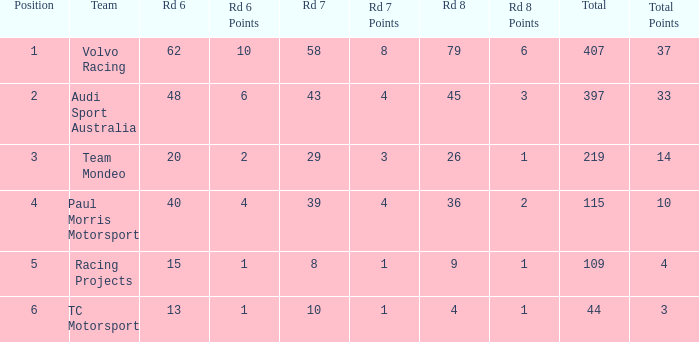What is the average value for Rd 8 in a position less than 2 for Audi Sport Australia? None. 